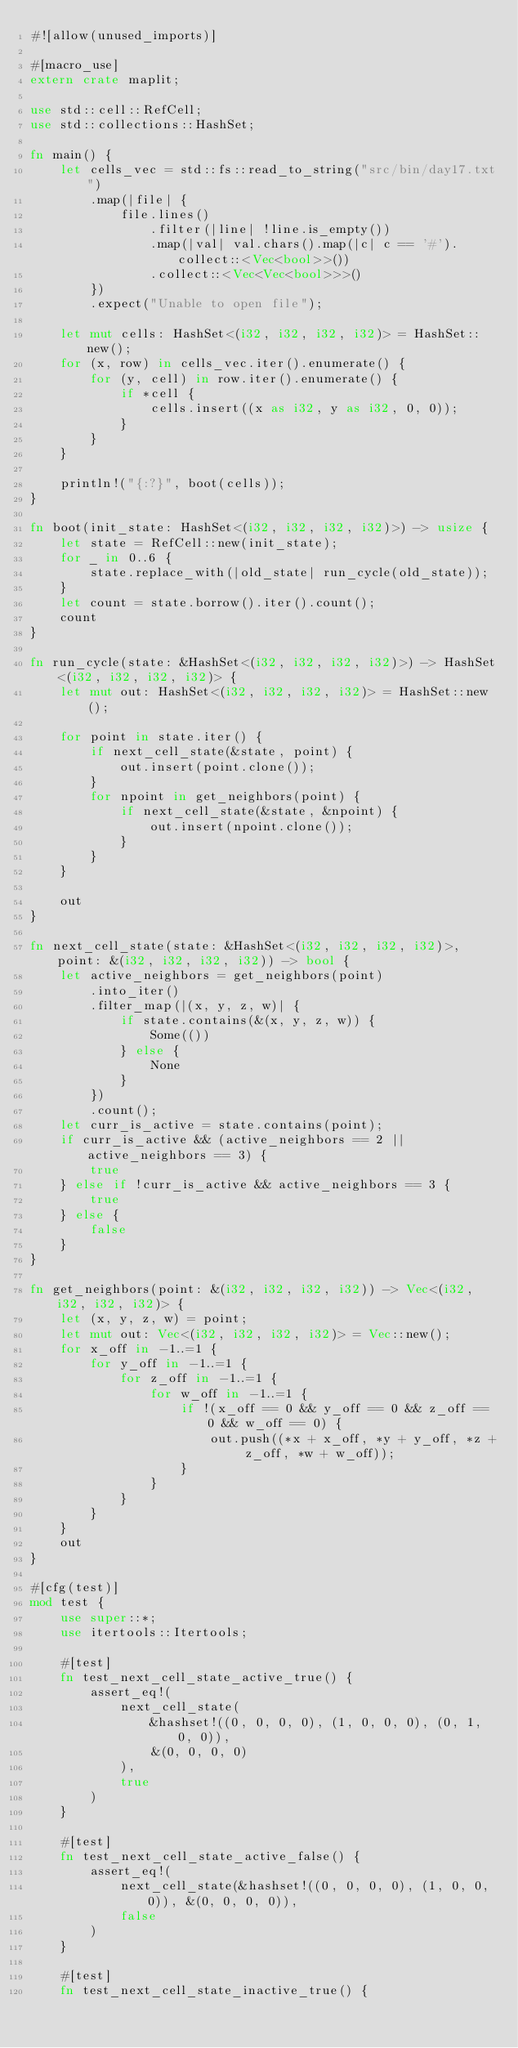Convert code to text. <code><loc_0><loc_0><loc_500><loc_500><_Rust_>#![allow(unused_imports)]

#[macro_use]
extern crate maplit;

use std::cell::RefCell;
use std::collections::HashSet;

fn main() {
    let cells_vec = std::fs::read_to_string("src/bin/day17.txt")
        .map(|file| {
            file.lines()
                .filter(|line| !line.is_empty())
                .map(|val| val.chars().map(|c| c == '#').collect::<Vec<bool>>())
                .collect::<Vec<Vec<bool>>>()
        })
        .expect("Unable to open file");

    let mut cells: HashSet<(i32, i32, i32, i32)> = HashSet::new();
    for (x, row) in cells_vec.iter().enumerate() {
        for (y, cell) in row.iter().enumerate() {
            if *cell {
                cells.insert((x as i32, y as i32, 0, 0));
            }
        }
    }

    println!("{:?}", boot(cells));
}

fn boot(init_state: HashSet<(i32, i32, i32, i32)>) -> usize {
    let state = RefCell::new(init_state);
    for _ in 0..6 {
        state.replace_with(|old_state| run_cycle(old_state));
    }
    let count = state.borrow().iter().count();
    count
}

fn run_cycle(state: &HashSet<(i32, i32, i32, i32)>) -> HashSet<(i32, i32, i32, i32)> {
    let mut out: HashSet<(i32, i32, i32, i32)> = HashSet::new();

    for point in state.iter() {
        if next_cell_state(&state, point) {
            out.insert(point.clone());
        }
        for npoint in get_neighbors(point) {
            if next_cell_state(&state, &npoint) {
                out.insert(npoint.clone());
            }
        }
    }

    out
}

fn next_cell_state(state: &HashSet<(i32, i32, i32, i32)>, point: &(i32, i32, i32, i32)) -> bool {
    let active_neighbors = get_neighbors(point)
        .into_iter()
        .filter_map(|(x, y, z, w)| {
            if state.contains(&(x, y, z, w)) {
                Some(())
            } else {
                None
            }
        })
        .count();
    let curr_is_active = state.contains(point);
    if curr_is_active && (active_neighbors == 2 || active_neighbors == 3) {
        true
    } else if !curr_is_active && active_neighbors == 3 {
        true
    } else {
        false
    }
}

fn get_neighbors(point: &(i32, i32, i32, i32)) -> Vec<(i32, i32, i32, i32)> {
    let (x, y, z, w) = point;
    let mut out: Vec<(i32, i32, i32, i32)> = Vec::new();
    for x_off in -1..=1 {
        for y_off in -1..=1 {
            for z_off in -1..=1 {
                for w_off in -1..=1 {
                    if !(x_off == 0 && y_off == 0 && z_off == 0 && w_off == 0) {
                        out.push((*x + x_off, *y + y_off, *z + z_off, *w + w_off));
                    }
                }
            }
        }
    }
    out
}

#[cfg(test)]
mod test {
    use super::*;
    use itertools::Itertools;

    #[test]
    fn test_next_cell_state_active_true() {
        assert_eq!(
            next_cell_state(
                &hashset!((0, 0, 0, 0), (1, 0, 0, 0), (0, 1, 0, 0)),
                &(0, 0, 0, 0)
            ),
            true
        )
    }

    #[test]
    fn test_next_cell_state_active_false() {
        assert_eq!(
            next_cell_state(&hashset!((0, 0, 0, 0), (1, 0, 0, 0)), &(0, 0, 0, 0)),
            false
        )
    }

    #[test]
    fn test_next_cell_state_inactive_true() {</code> 